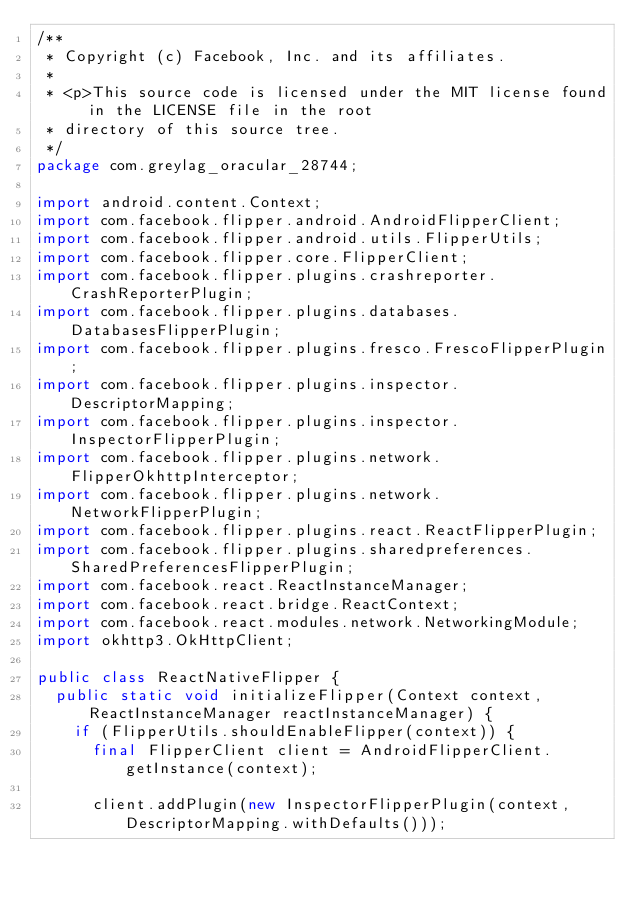Convert code to text. <code><loc_0><loc_0><loc_500><loc_500><_Java_>/**
 * Copyright (c) Facebook, Inc. and its affiliates.
 *
 * <p>This source code is licensed under the MIT license found in the LICENSE file in the root
 * directory of this source tree.
 */
package com.greylag_oracular_28744;

import android.content.Context;
import com.facebook.flipper.android.AndroidFlipperClient;
import com.facebook.flipper.android.utils.FlipperUtils;
import com.facebook.flipper.core.FlipperClient;
import com.facebook.flipper.plugins.crashreporter.CrashReporterPlugin;
import com.facebook.flipper.plugins.databases.DatabasesFlipperPlugin;
import com.facebook.flipper.plugins.fresco.FrescoFlipperPlugin;
import com.facebook.flipper.plugins.inspector.DescriptorMapping;
import com.facebook.flipper.plugins.inspector.InspectorFlipperPlugin;
import com.facebook.flipper.plugins.network.FlipperOkhttpInterceptor;
import com.facebook.flipper.plugins.network.NetworkFlipperPlugin;
import com.facebook.flipper.plugins.react.ReactFlipperPlugin;
import com.facebook.flipper.plugins.sharedpreferences.SharedPreferencesFlipperPlugin;
import com.facebook.react.ReactInstanceManager;
import com.facebook.react.bridge.ReactContext;
import com.facebook.react.modules.network.NetworkingModule;
import okhttp3.OkHttpClient;

public class ReactNativeFlipper {
  public static void initializeFlipper(Context context, ReactInstanceManager reactInstanceManager) {
    if (FlipperUtils.shouldEnableFlipper(context)) {
      final FlipperClient client = AndroidFlipperClient.getInstance(context);

      client.addPlugin(new InspectorFlipperPlugin(context, DescriptorMapping.withDefaults()));</code> 